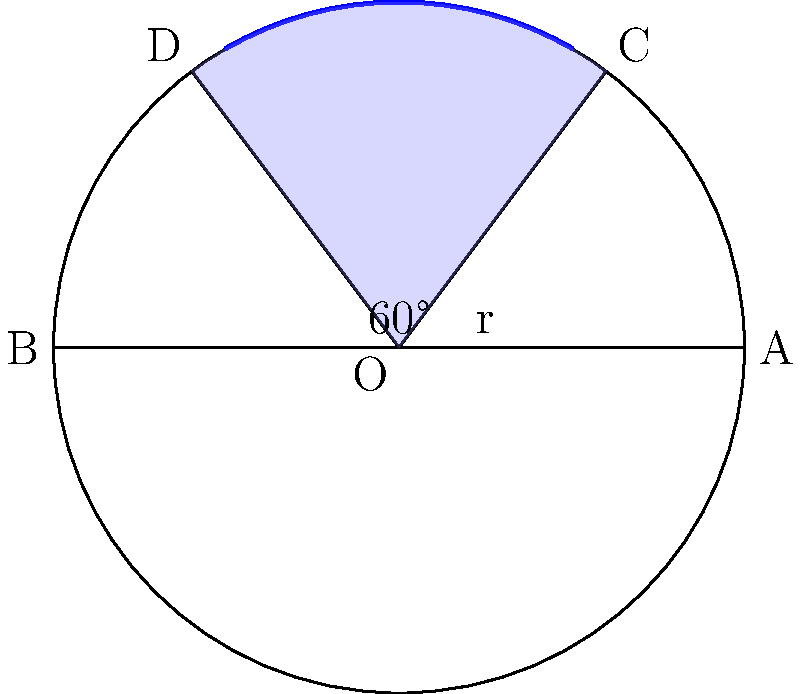As a professional kiteboarder, you know that the "power zone" of a kite is crucial for generating maximum pull. This zone can be represented by a circular segment in the kite's wind window. In the diagram, the kite's wind window is represented by a circle with radius 10 meters. The power zone is the blue shaded area, forming a circular segment with a central angle of 60°. Calculate the area of the power zone to the nearest square meter. Let's approach this step-by-step:

1) The area of a circular segment is given by the formula:
   $$A = r^2 (\theta - \sin\theta)$$
   where $r$ is the radius and $\theta$ is the central angle in radians.

2) We're given the radius $r = 10$ meters and the central angle of 60°.

3) We need to convert 60° to radians:
   $$\theta = 60° \times \frac{\pi}{180°} = \frac{\pi}{3} \approx 1.0472 \text{ radians}$$

4) Now we can substitute these values into our formula:
   $$A = 10^2 (\frac{\pi}{3} - \sin(\frac{\pi}{3}))$$

5) We know that $\sin(\frac{\pi}{3}) = \frac{\sqrt{3}}{2}$

6) Let's calculate:
   $$A = 100 (\frac{\pi}{3} - \frac{\sqrt{3}}{2})$$
   $$A = 100 (1.0472 - 0.8660)$$
   $$A = 100 (0.1812)$$
   $$A = 18.12 \text{ square meters}$$

7) Rounding to the nearest square meter:
   $$A \approx 18 \text{ square meters}$$
Answer: 18 square meters 